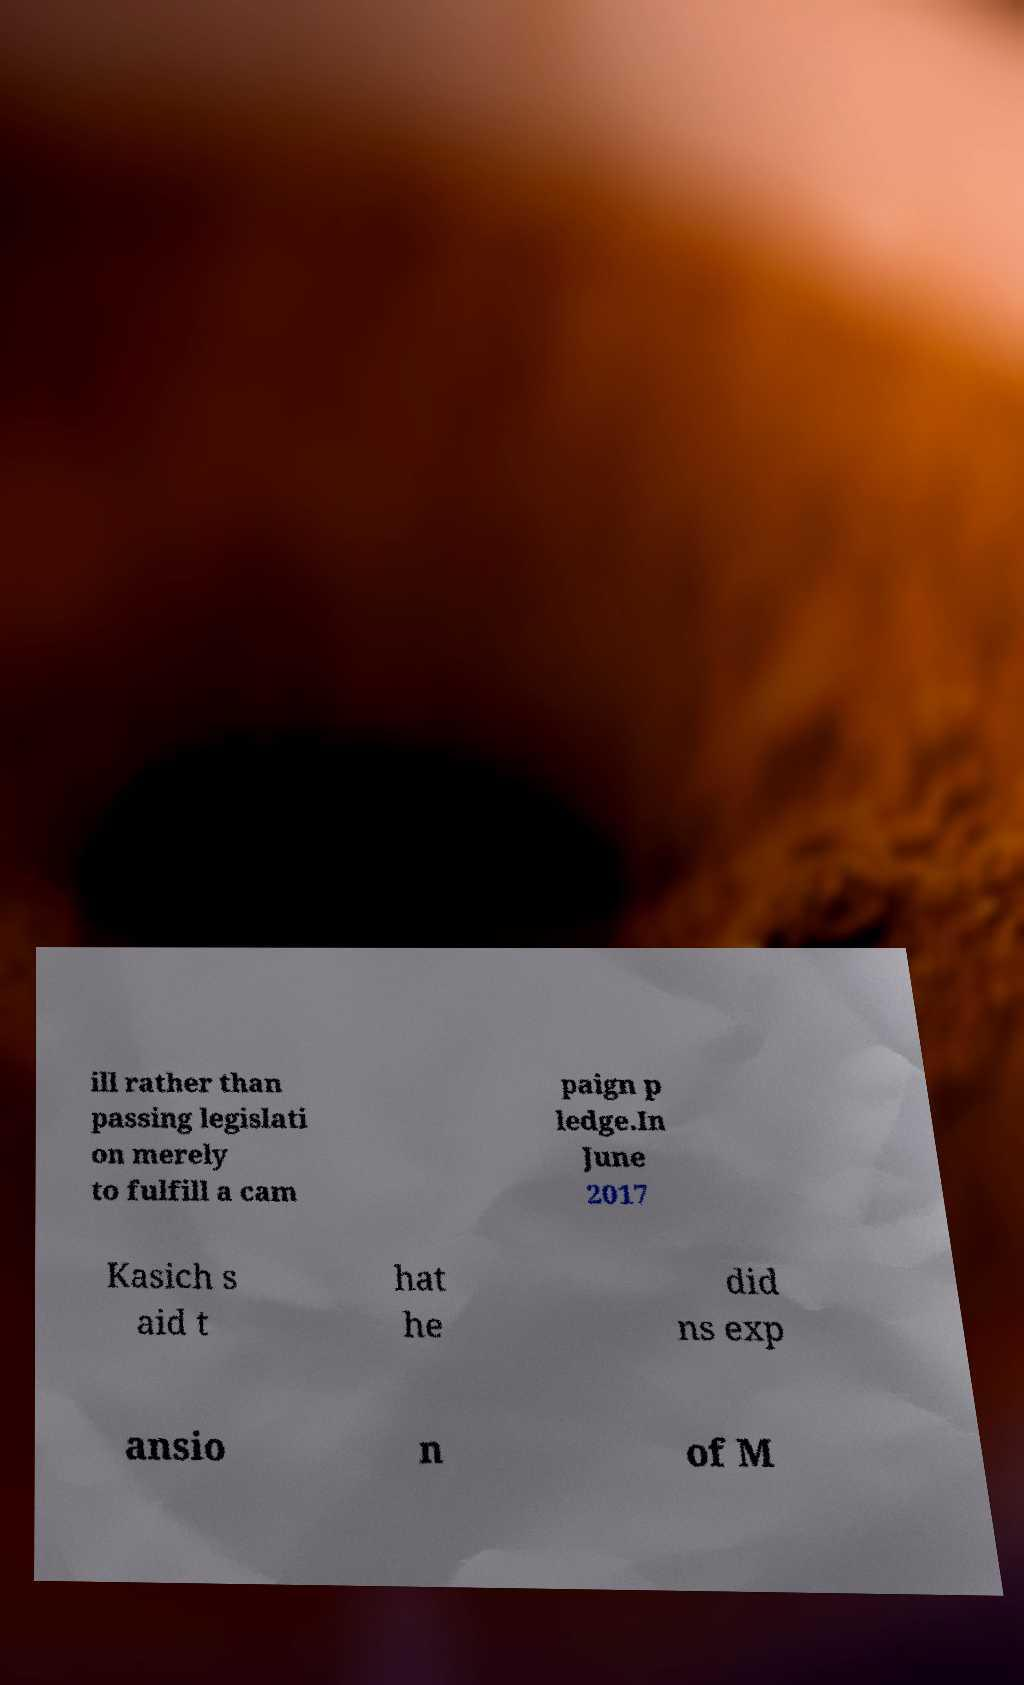For documentation purposes, I need the text within this image transcribed. Could you provide that? ill rather than passing legislati on merely to fulfill a cam paign p ledge.In June 2017 Kasich s aid t hat he did ns exp ansio n of M 